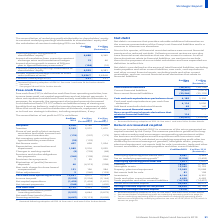According to Unilever Plc's financial document, What is Net Debt? Net debt is a measure that provides valuable additional information on the summary presentation of the Group’s net financial liabilities and is a measure in common use elsewhere.. The document states: "Net debt is a measure that provides valuable additional information on the summary presentation of the Group’s net financial liabilities and is a meas..." Also, How is Net Debt calculated? excess of total financial liabilities, excluding trade payables and other current liabilities, over cash, cash equivalents and other current financial assets. The document states: "Net debt is now defined as the excess of total financial liabilities, excluding trade payables and other current liabilities, over cash, cash equivale..." Also, What is excluded from Net Debt calculation? trade and other current receivables, and non-current financial asset derivatives that relate to financial liabilities.. The document states: "ents and other current financial assets, excluding trade and other current receivables, and non-current financial asset derivatives that relate to fin..." Also, can you calculate: What is the average total financial liabilities? To answer this question, I need to perform calculations using the financial data. The calculation is: - (28,257 + 26,738) / 2, which equals -27497.5 (in millions). This is based on the information: "Total financial liabilities (28,257) (26,738) Total financial liabilities (28,257) (26,738)..." The key data points involved are: 26,738, 28,257. Also, can you calculate: What is the change in the Cash and cash equivalents as per balance sheet from 2018 to 2019? Based on the calculation: (4,185 - 3,230), the result is 955 (in millions). This is based on the information: "h and cash equivalents as per balance sheet 4,185 3,230 Cash and cash equivalents as per cash flow statement 4,116 3,090 Cash and cash equivalents as per balance sheet 4,185 3,230 Cash and cash equiva..." The key data points involved are: 3,230, 4,185. Also, can you calculate: What is the percentage change in Net Debt? To answer this question, I need to perform calculations using the financial data. The calculation is: (23,051 / 22,634) - 1, which equals 1.84 (percentage). This is based on the information: "Net debt (23,051) (22,634) Net debt (23,051) (22,634)..." The key data points involved are: 22,634, 23,051. 